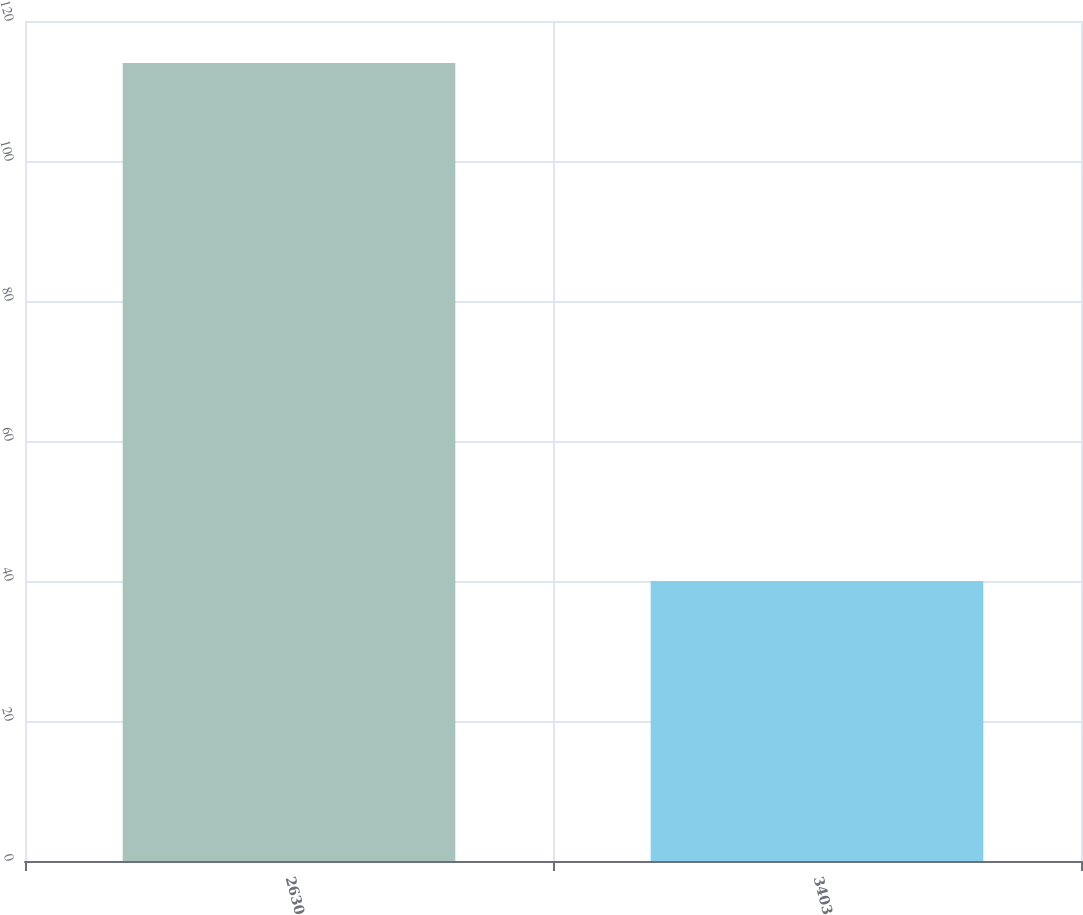Convert chart to OTSL. <chart><loc_0><loc_0><loc_500><loc_500><bar_chart><fcel>2630<fcel>3403<nl><fcel>114<fcel>40<nl></chart> 